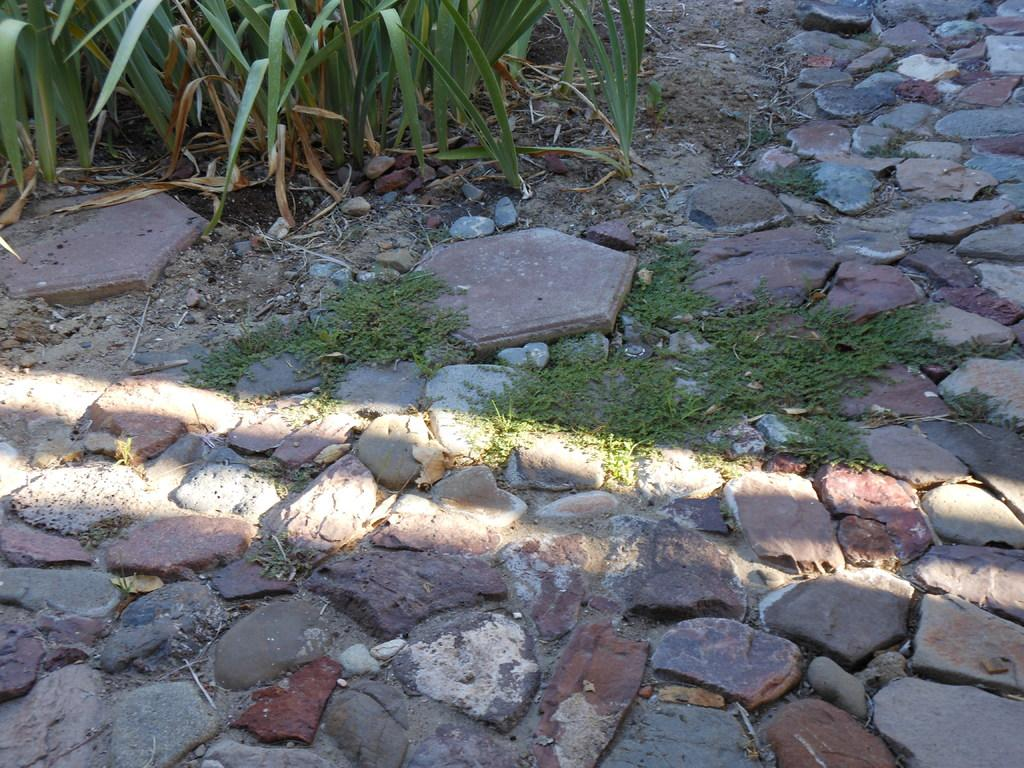What type of objects are on the ground in the image? There are stones and plants on the ground in the image. Can you describe the plants in the image? The provided facts do not give specific details about the plants, but they are present on the ground. What type of meal is being prepared by the maid in the image? There is no maid or meal preparation present in the image; it only features stones and plants on the ground. What is the opinion of the person in the image about the plants? The provided facts do not give any information about a person's opinion in the image, nor is there a person present. 